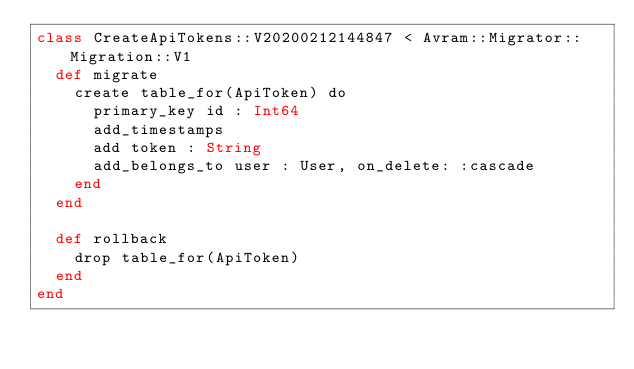<code> <loc_0><loc_0><loc_500><loc_500><_Crystal_>class CreateApiTokens::V20200212144847 < Avram::Migrator::Migration::V1
  def migrate
    create table_for(ApiToken) do
      primary_key id : Int64
      add_timestamps
      add token : String
      add_belongs_to user : User, on_delete: :cascade
    end
  end

  def rollback
    drop table_for(ApiToken)
  end
end
</code> 